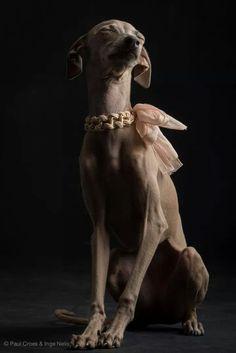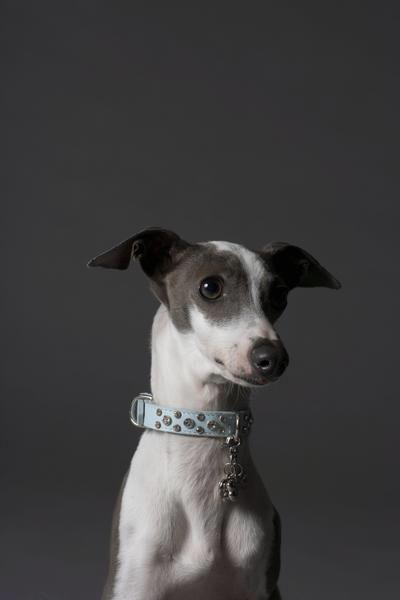The first image is the image on the left, the second image is the image on the right. Examine the images to the left and right. Is the description "All the dogs in the images are posing for portraits wearing collars." accurate? Answer yes or no. Yes. 